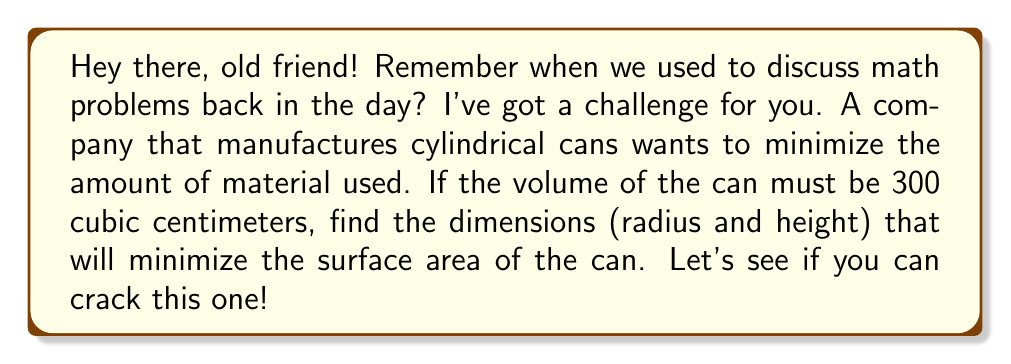Show me your answer to this math problem. Alright, let's approach this step-by-step:

1) First, we need to set up our equations. Let $r$ be the radius and $h$ be the height of the cylinder.

2) The volume of a cylinder is given by $V = \pi r^2 h$. We're told this must be 300 cm³, so:

   $$\pi r^2 h = 300$$

3) The surface area of a cylinder (including top and bottom) is given by $S = 2\pi r^2 + 2\pi rh$

4) We can solve the volume equation for $h$:

   $$h = \frac{300}{\pi r^2}$$

5) Now, let's substitute this into our surface area equation:

   $$S = 2\pi r^2 + 2\pi r(\frac{300}{\pi r^2}) = 2\pi r^2 + \frac{600}{r}$$

6) To find the minimum, we need to differentiate $S$ with respect to $r$ and set it to zero:

   $$\frac{dS}{dr} = 4\pi r - \frac{600}{r^2} = 0$$

7) Solving this equation:

   $$4\pi r^3 = 600$$
   $$r^3 = \frac{600}{4\pi} = \frac{150}{\pi}$$
   $$r = \sqrt[3]{\frac{150}{\pi}} \approx 3.29 \text{ cm}$$

8) Now we can find $h$ using the equation from step 4:

   $$h = \frac{300}{\pi r^2} = \frac{300}{\pi (\frac{150}{\pi})^{2/3}} = 2r = 2(3.29) \approx 6.58 \text{ cm}$$

9) We can verify this is a minimum by checking the second derivative is positive at this point.
Answer: $r \approx 3.29 \text{ cm}, h \approx 6.58 \text{ cm}$ 